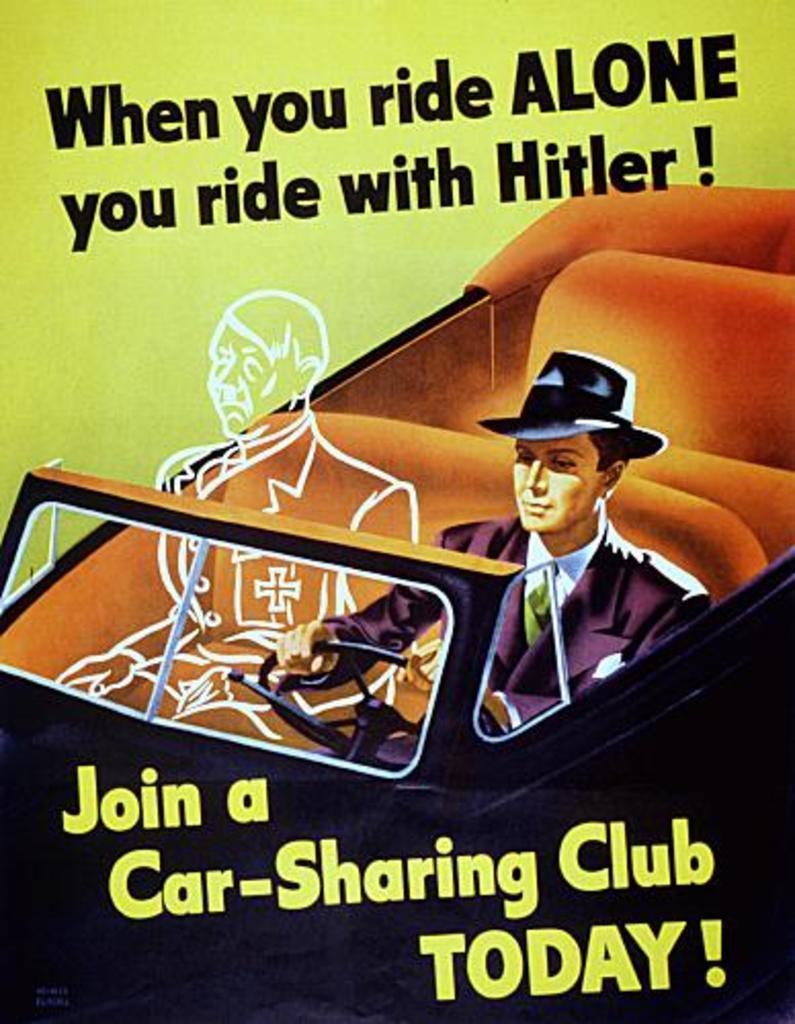In one or two sentences, can you explain what this image depicts? This might be a poster, in this image in the center there is one vehicle. In the vehicle there is one person sitting, beside him there is a drawing of one person and at the top and bottom of the image there is text. 